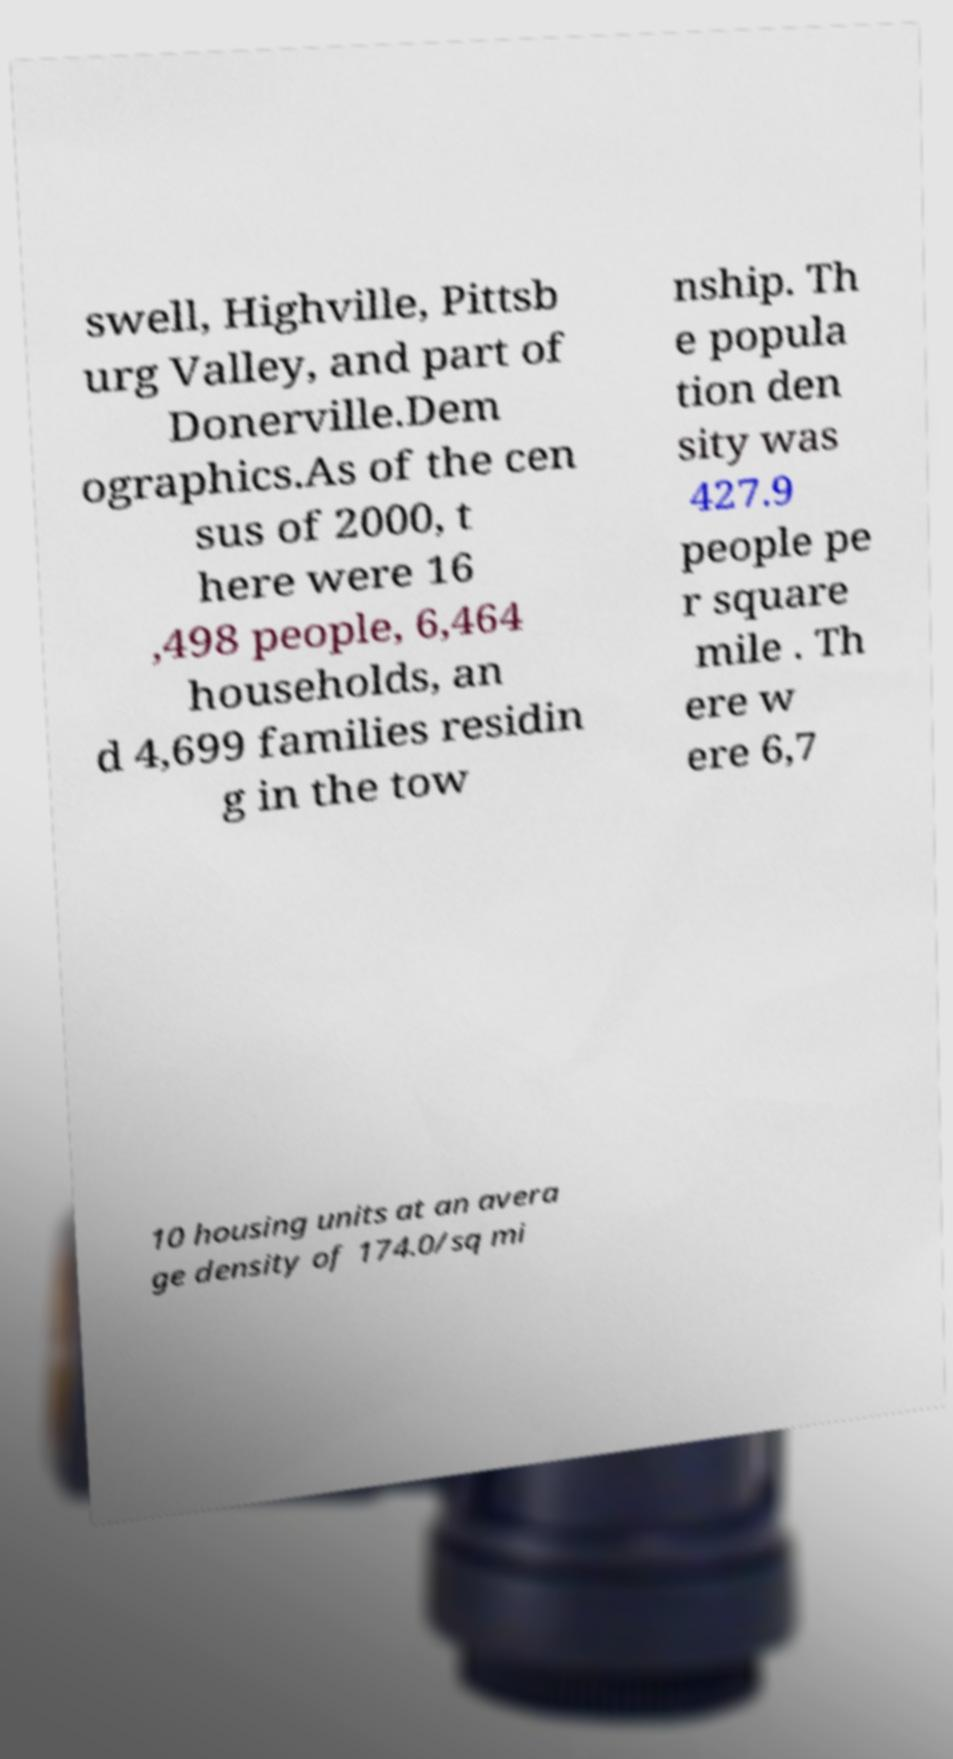What messages or text are displayed in this image? I need them in a readable, typed format. swell, Highville, Pittsb urg Valley, and part of Donerville.Dem ographics.As of the cen sus of 2000, t here were 16 ,498 people, 6,464 households, an d 4,699 families residin g in the tow nship. Th e popula tion den sity was 427.9 people pe r square mile . Th ere w ere 6,7 10 housing units at an avera ge density of 174.0/sq mi 